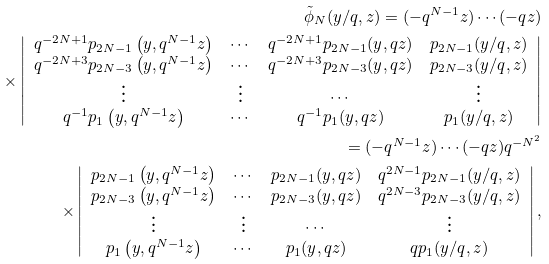<formula> <loc_0><loc_0><loc_500><loc_500>\tilde { \phi } _ { N } ( y / q , z ) = ( - q ^ { N - 1 } z ) \cdots ( - q z ) \\ \times \left | \begin{array} { c c c c } q ^ { - 2 N + 1 } p _ { 2 N - 1 } \left ( y , q ^ { N - 1 } z \right ) & \cdots & q ^ { - 2 N + 1 } p _ { 2 N - 1 } ( y , q z ) & p _ { 2 N - 1 } ( y / q , z ) \\ q ^ { - 2 N + 3 } p _ { 2 N - 3 } \left ( y , q ^ { N - 1 } z \right ) & \cdots & q ^ { - 2 N + 3 } p _ { 2 N - 3 } ( y , q z ) & p _ { 2 N - 3 } ( y / q , z ) \\ \vdots & \vdots & \cdots & \vdots \\ q ^ { - 1 } p _ { 1 } \left ( y , q ^ { N - 1 } z \right ) & \cdots & q ^ { - 1 } p _ { 1 } ( y , q z ) & p _ { 1 } ( y / q , z ) \end{array} \right | \\ = ( - q ^ { N - 1 } z ) \cdots ( - q z ) q ^ { - N ^ { 2 } } \\ \times \left | \begin{array} { c c c c } p _ { 2 N - 1 } \left ( y , q ^ { N - 1 } z \right ) & \cdots & p _ { 2 N - 1 } ( y , q z ) & q ^ { 2 N - 1 } p _ { 2 N - 1 } ( y / q , z ) \\ p _ { 2 N - 3 } \left ( y , q ^ { N - 1 } z \right ) & \cdots & p _ { 2 N - 3 } ( y , q z ) & q ^ { 2 N - 3 } p _ { 2 N - 3 } ( y / q , z ) \\ \vdots & \vdots & \cdots & \vdots \\ p _ { 1 } \left ( y , q ^ { N - 1 } z \right ) & \cdots & p _ { 1 } ( y , q z ) & q p _ { 1 } ( y / q , z ) \end{array} \right | ,</formula> 